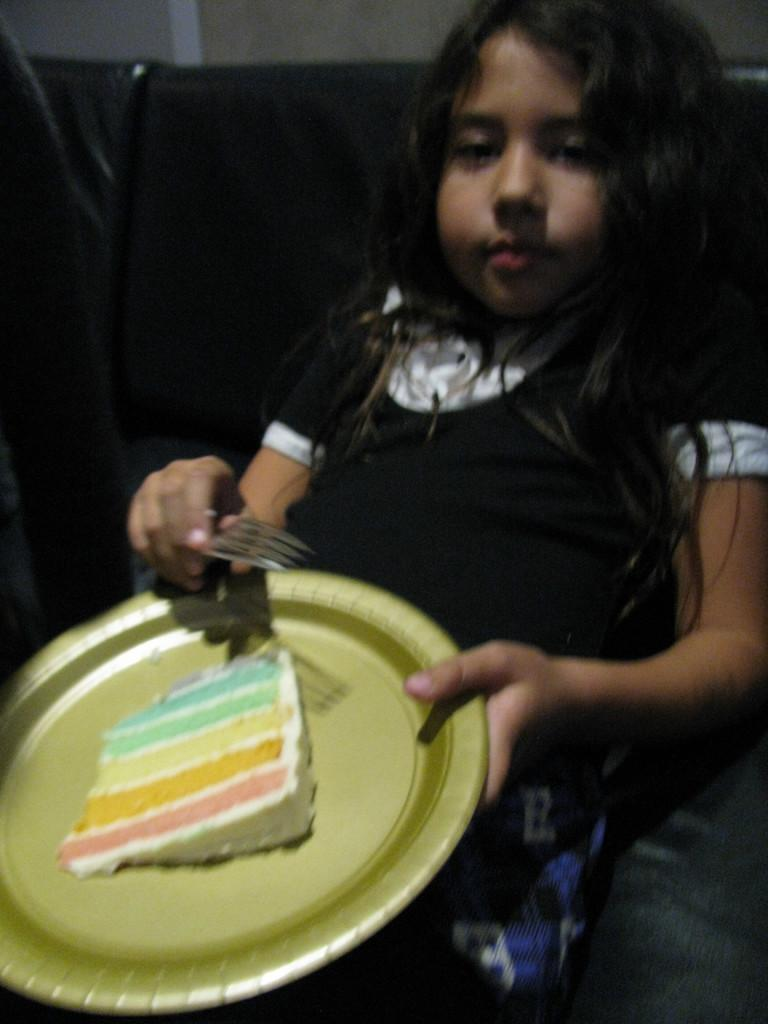What is present in the image? There is a person in the image. What is the person wearing? The person is wearing a dress. What is the person holding in the image? The person is holding a plate and fork. What can be seen in the background of the image? The background of the image is black. What is on the plate that the person is holding? There is food in the plate. What type of calculator can be seen on the person's wrist in the image? There is no calculator present in the image. Can you tell me what time it is according to the watch on the person's hand in the image? There is no watch present in the image. 